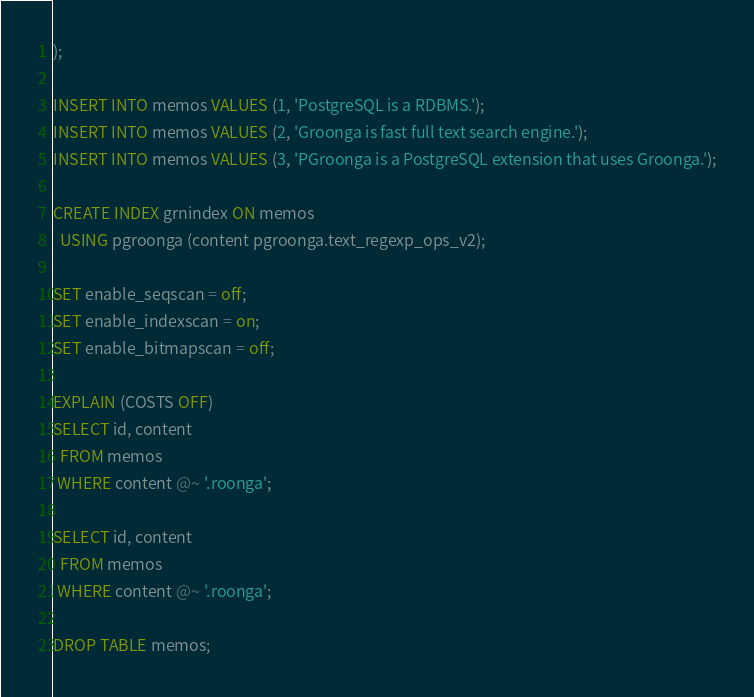<code> <loc_0><loc_0><loc_500><loc_500><_SQL_>);

INSERT INTO memos VALUES (1, 'PostgreSQL is a RDBMS.');
INSERT INTO memos VALUES (2, 'Groonga is fast full text search engine.');
INSERT INTO memos VALUES (3, 'PGroonga is a PostgreSQL extension that uses Groonga.');

CREATE INDEX grnindex ON memos
  USING pgroonga (content pgroonga.text_regexp_ops_v2);

SET enable_seqscan = off;
SET enable_indexscan = on;
SET enable_bitmapscan = off;

EXPLAIN (COSTS OFF)
SELECT id, content
  FROM memos
 WHERE content @~ '.roonga';

SELECT id, content
  FROM memos
 WHERE content @~ '.roonga';

DROP TABLE memos;
</code> 